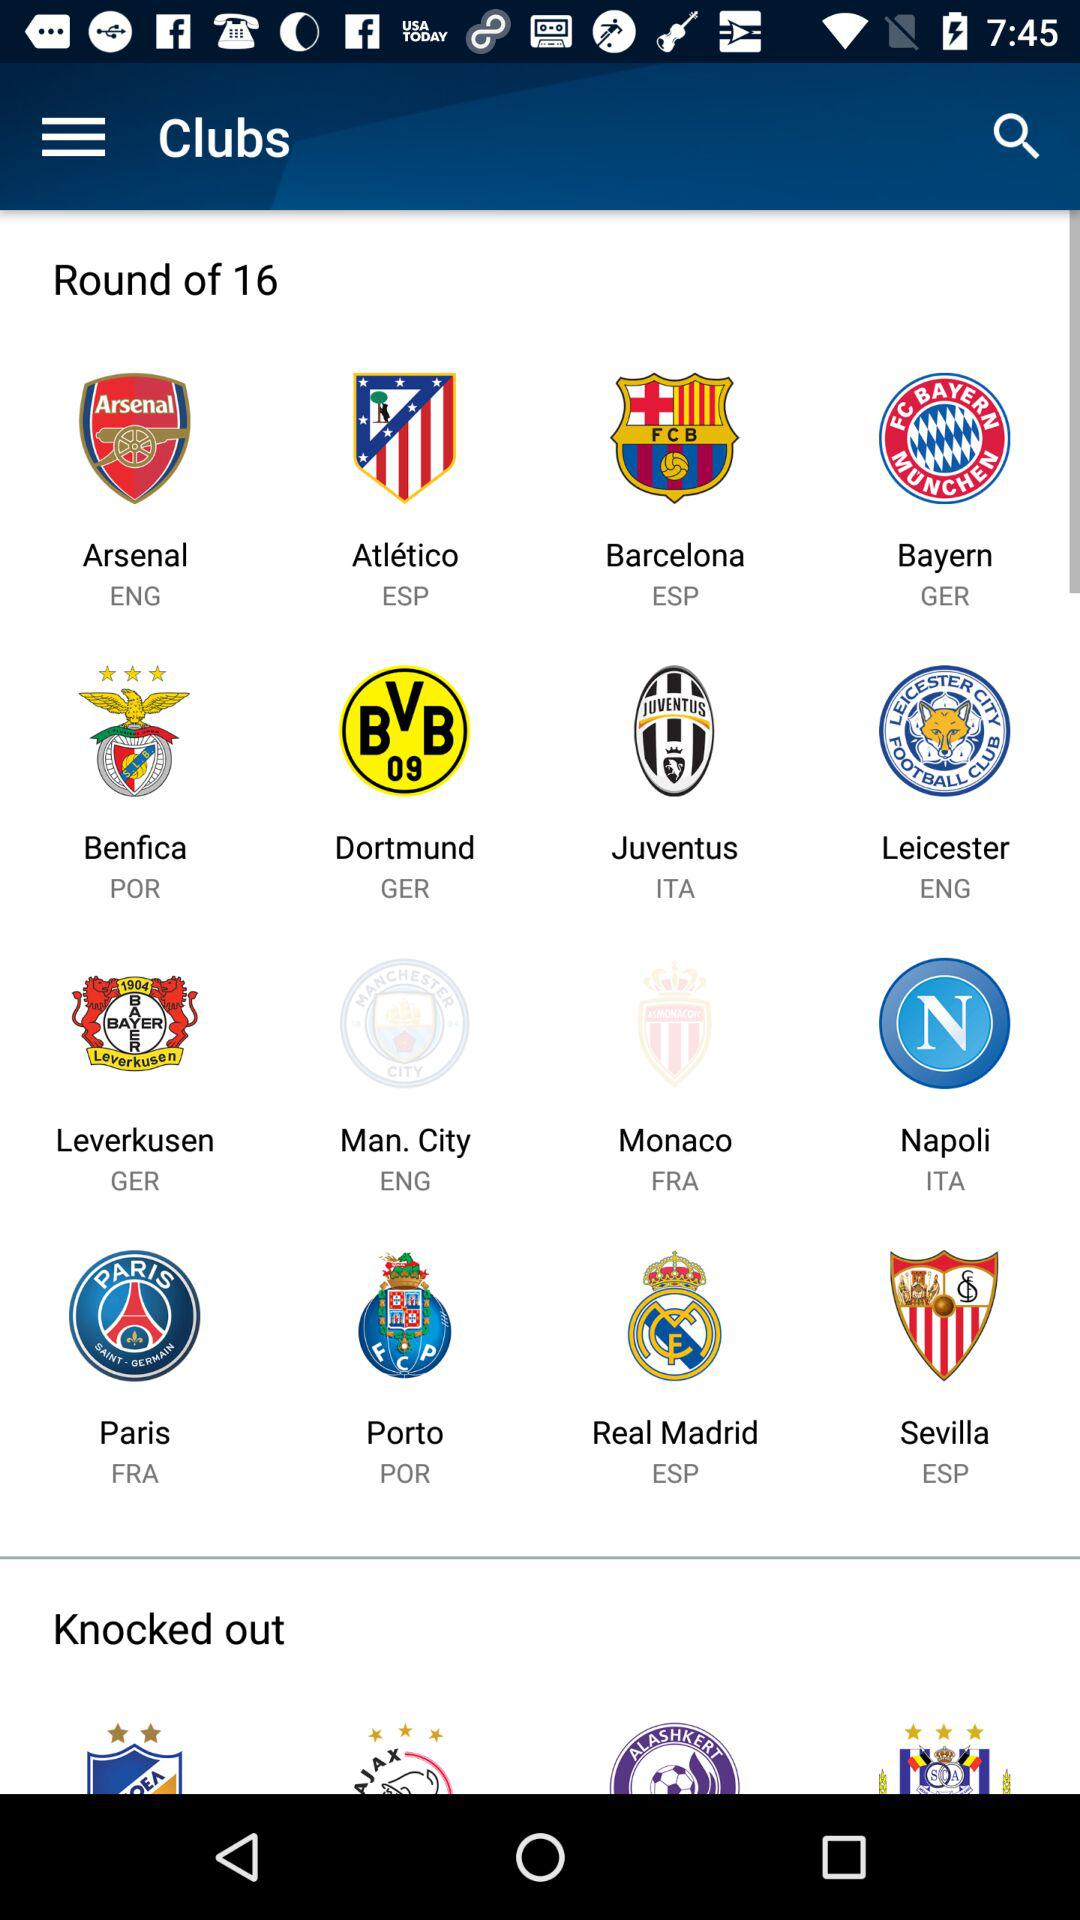How many teams are in the round of 16?
Answer the question using a single word or phrase. 16 